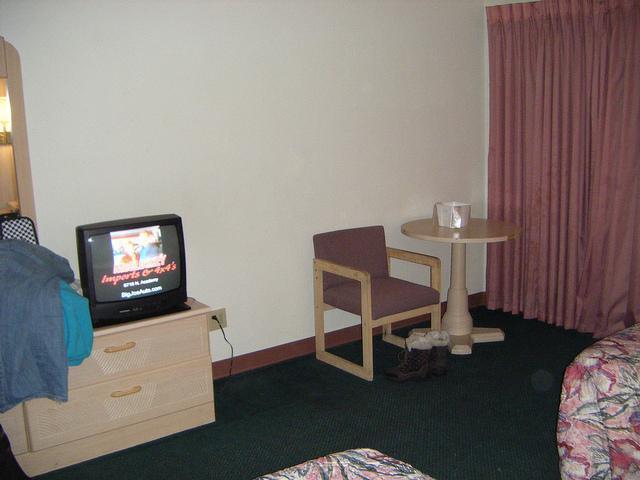How many tvs are in the photo?
Give a very brief answer. 1. How many levels does this bus have?
Give a very brief answer. 0. 